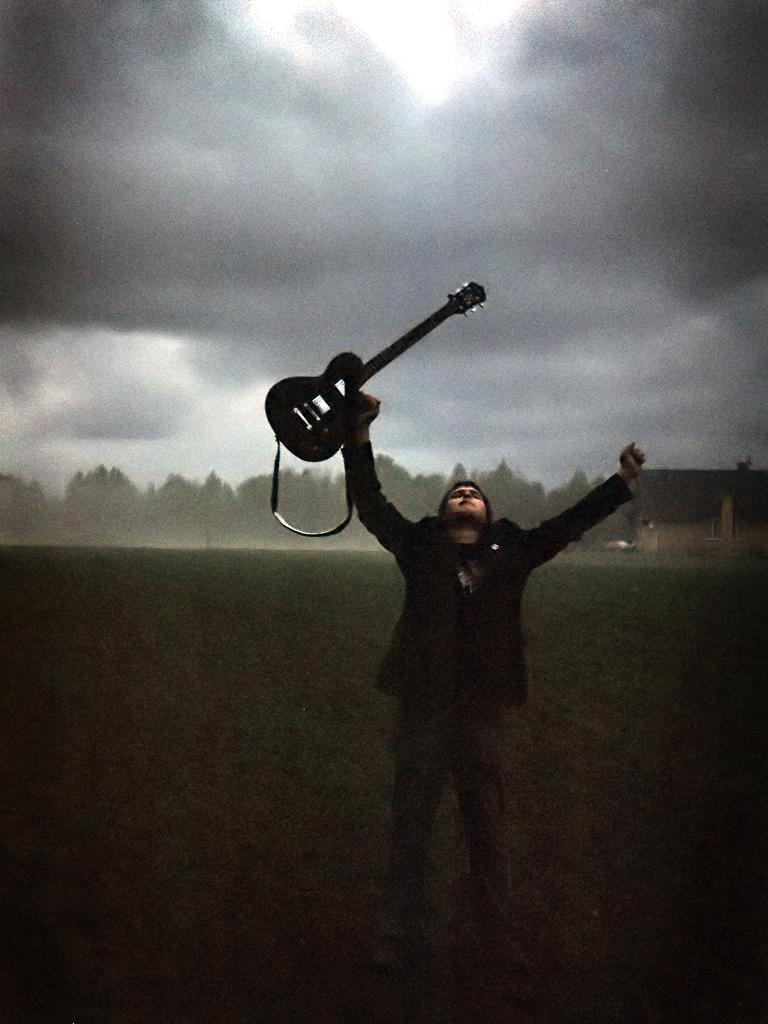What is the main subject of the image? There is a man in the image. What is the man doing in the image? The man is standing in the image. What object is the man holding in his right hand? The man is holding a guitar in his right hand. What can be seen in the background of the image? There are heavy clouds and many trees in the background of the image. Can you hear the man laughing while playing the guitar in the image? There is no sound in the image, so we cannot hear the man laughing or playing the guitar. Is there a hill visible in the image? There is no hill mentioned or visible in the image; it only features a man, a guitar, heavy clouds, and many trees. 